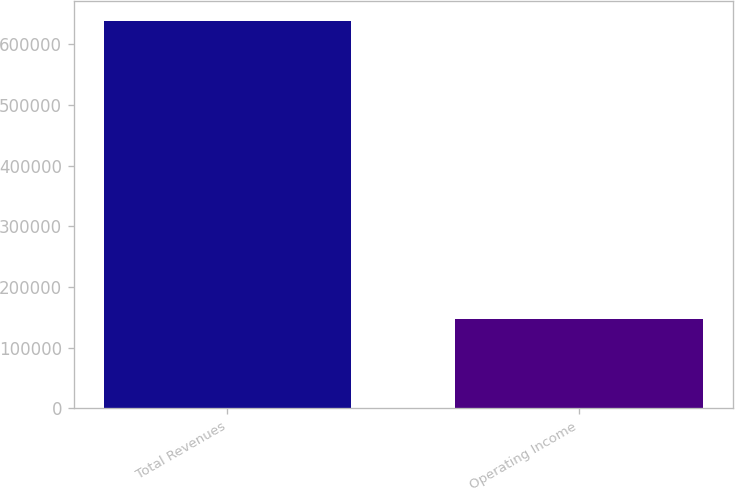Convert chart. <chart><loc_0><loc_0><loc_500><loc_500><bar_chart><fcel>Total Revenues<fcel>Operating Income<nl><fcel>638898<fcel>146907<nl></chart> 